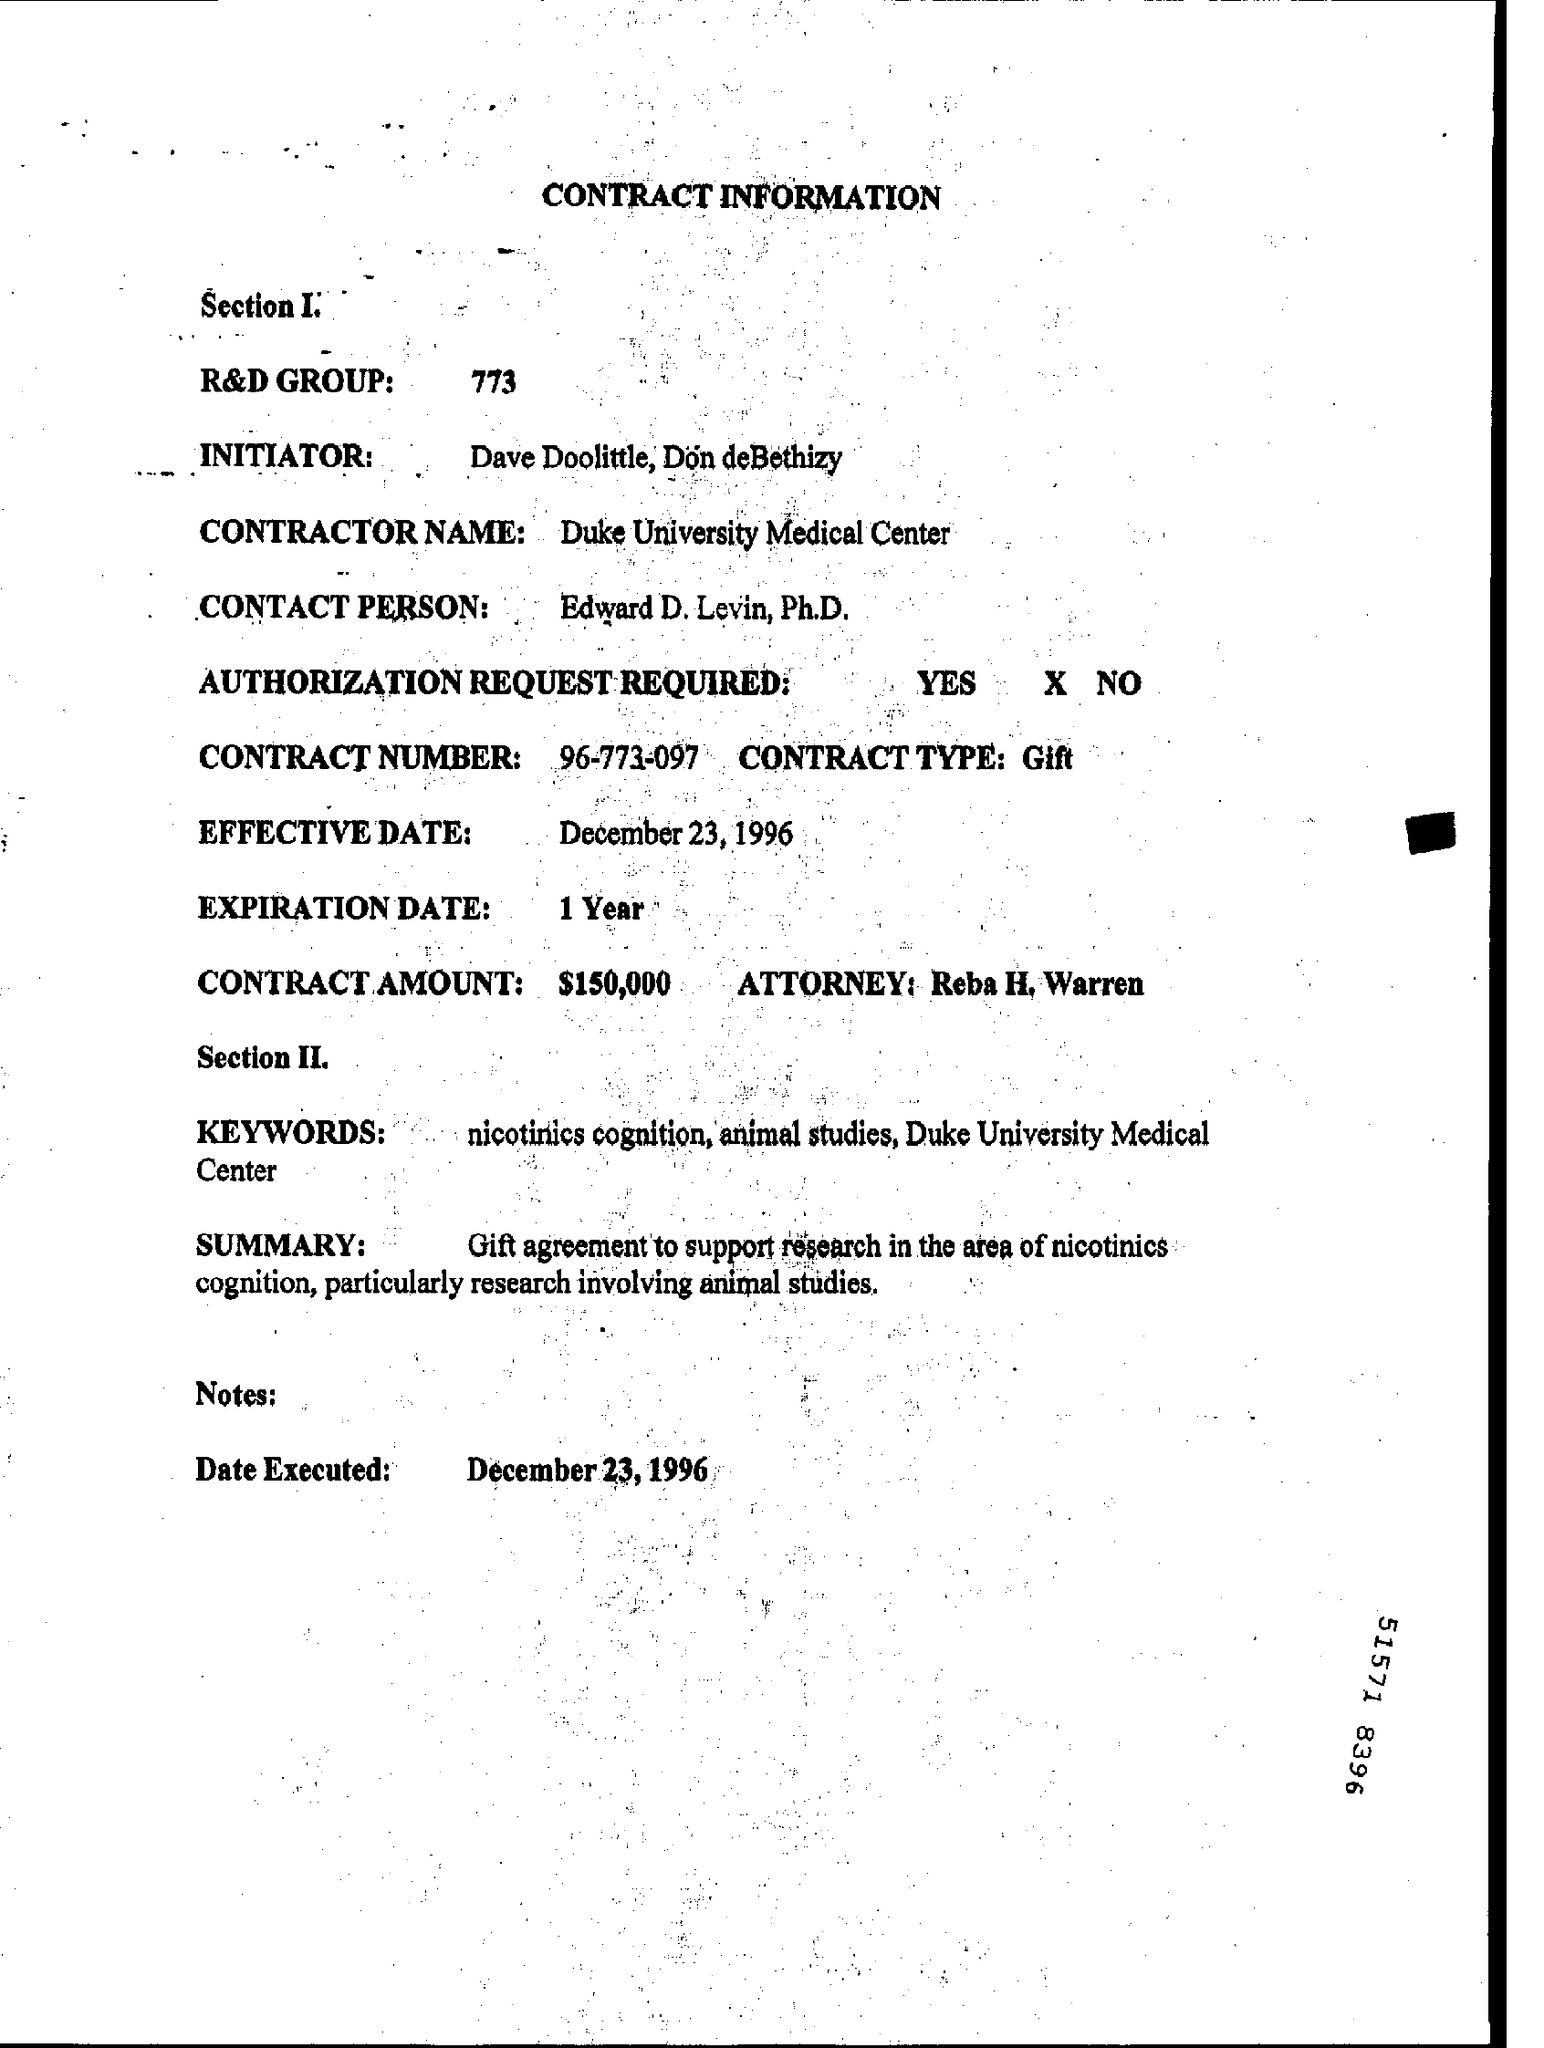What is the expiration date?
Give a very brief answer. 1 Year. What is the contract number?
Offer a very short reply. 96-773-097. What is the name of the attorney?
Offer a very short reply. Reba H. Warren. What is the number for r&d group?
Offer a terse response. 773. 